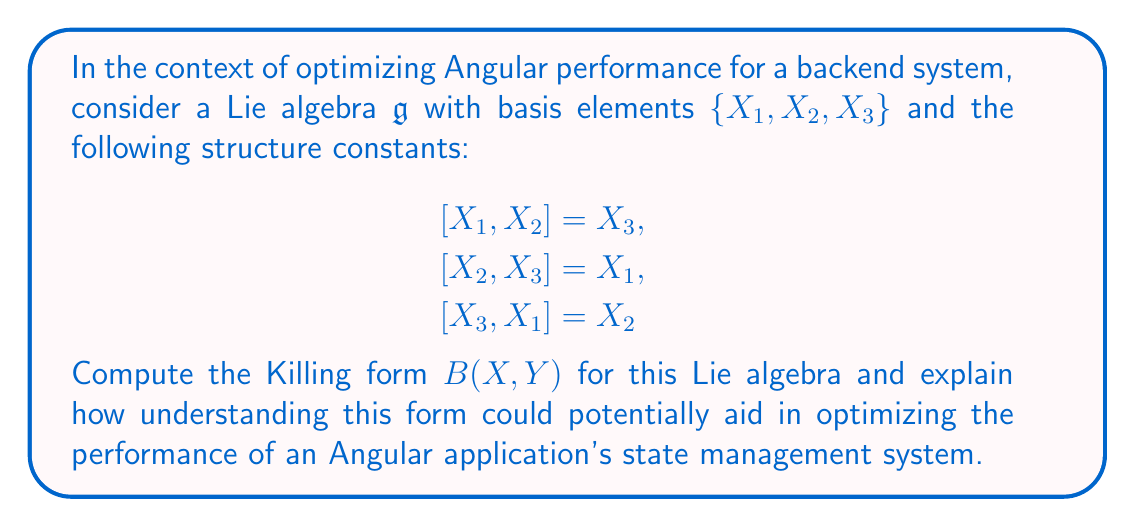What is the answer to this math problem? To solve this problem and understand its relevance to Angular performance optimization, let's break it down into steps:

1. Recall that the Killing form $B(X, Y)$ for a Lie algebra $\mathfrak{g}$ is defined as:

   $$B(X, Y) = \text{tr}(\text{ad}_X \circ \text{ad}_Y)$$

   where $\text{ad}_X$ is the adjoint representation of $X$.

2. To compute the Killing form, we need to find the matrices of $\text{ad}_{X_i}$ for each basis element:

   For $\text{ad}_{X_1}$:
   $$\text{ad}_{X_1}(X_1) = 0$$
   $$\text{ad}_{X_1}(X_2) = X_3$$
   $$\text{ad}_{X_1}(X_3) = -X_2$$

   So, $\text{ad}_{X_1} = \begin{pmatrix} 0 & 0 & 0 \\ 0 & 0 & -1 \\ 0 & 1 & 0 \end{pmatrix}$

   Similarly:
   $\text{ad}_{X_2} = \begin{pmatrix} 0 & 0 & 1 \\ 0 & 0 & 0 \\ -1 & 0 & 0 \end{pmatrix}$
   $\text{ad}_{X_3} = \begin{pmatrix} 0 & -1 & 0 \\ 1 & 0 & 0 \\ 0 & 0 & 0 \end{pmatrix}$

3. Now, we can compute $B(X_i, X_j)$ for all pairs:

   $B(X_1, X_1) = \text{tr}(\text{ad}_{X_1} \circ \text{ad}_{X_1}) = -2$
   $B(X_2, X_2) = \text{tr}(\text{ad}_{X_2} \circ \text{ad}_{X_2}) = -2$
   $B(X_3, X_3) = \text{tr}(\text{ad}_{X_3} \circ \text{ad}_{X_3}) = -2$
   $B(X_1, X_2) = B(X_2, X_1) = \text{tr}(\text{ad}_{X_1} \circ \text{ad}_{X_2}) = 0$
   $B(X_1, X_3) = B(X_3, X_1) = \text{tr}(\text{ad}_{X_1} \circ \text{ad}_{X_3}) = 0$
   $B(X_2, X_3) = B(X_3, X_2) = \text{tr}(\text{ad}_{X_2} \circ \text{ad}_{X_3}) = 0$

4. Therefore, the Killing form matrix is:

   $$B = \begin{pmatrix} -2 & 0 & 0 \\ 0 & -2 & 0 \\ 0 & 0 & -2 \end{pmatrix}$$

5. Relevance to Angular performance optimization:
   Understanding the Killing form of a Lie algebra can be metaphorically applied to optimizing Angular's state management system. The Killing form provides information about the structure and symmetry of the Lie algebra, which can be analogous to the structure of your application's state.

   - The diagonal nature of the Killing form suggests that the basis elements (state components) are orthogonal, implying that they can be managed independently.
   - The uniform value (-2) on the diagonal indicates that all basis elements have equal "weight" or importance in the algebra structure.

   In the context of Angular performance optimization, this could translate to:
   
   a) Designing a state management system where different parts of the state are as independent as possible, reducing unnecessary updates and improving performance.
   b) Treating all state components with equal importance in terms of update frequency and optimization efforts.
   c) Using this structure to implement efficient change detection strategies, where updates to one part of the state don't unnecessarily trigger updates in unrelated parts.

   By organizing your Angular application's state management system in a way that mirrors the structure revealed by the Killing form, you may be able to achieve better performance through reduced coupling and more efficient updates.
Answer: The Killing form for the given Lie algebra is:

$$B = \begin{pmatrix} -2 & 0 & 0 \\ 0 & -2 & 0 \\ 0 & 0 & -2 \end{pmatrix}$$

This diagonal form suggests organizing the Angular application's state management system with orthogonal, equally weighted components to potentially improve performance through reduced coupling and more efficient updates. 